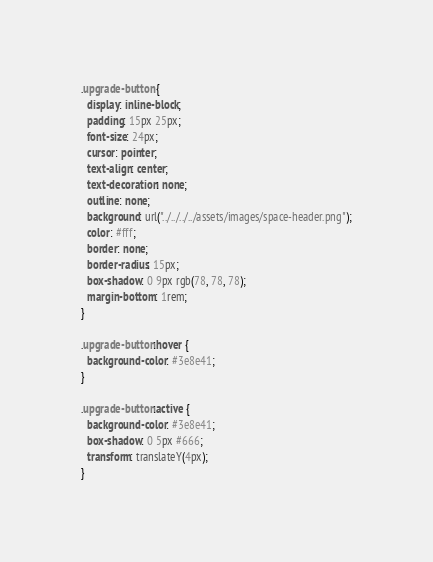Convert code to text. <code><loc_0><loc_0><loc_500><loc_500><_CSS_>.upgrade-button {
  display: inline-block;
  padding: 15px 25px;
  font-size: 24px;
  cursor: pointer;
  text-align: center;
  text-decoration: none;
  outline: none;
  background: url("../../../../assets/images/space-header.png");
  color: #fff;
  border: none;
  border-radius: 15px;
  box-shadow: 0 9px rgb(78, 78, 78);
  margin-bottom: 1rem;
}

.upgrade-button:hover {
  background-color: #3e8e41;
}

.upgrade-button:active {
  background-color: #3e8e41;
  box-shadow: 0 5px #666;
  transform: translateY(4px);
}
</code> 